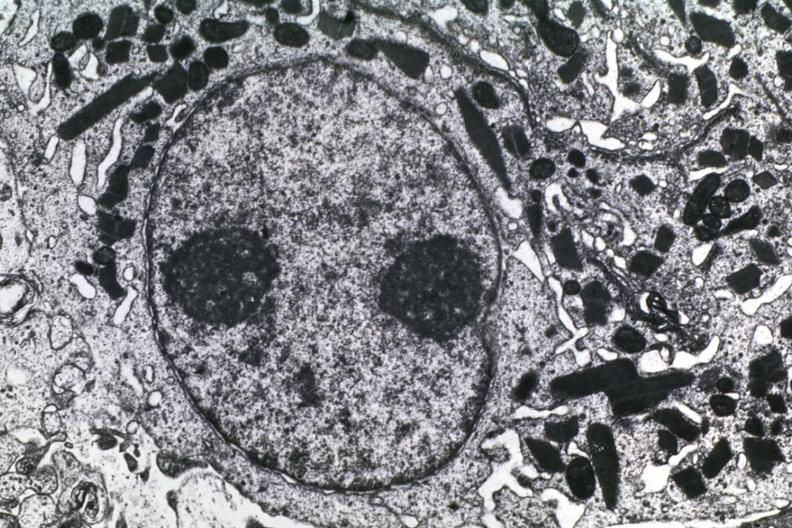what is present?
Answer the question using a single word or phrase. Subependymal giant cell astrocytoma 